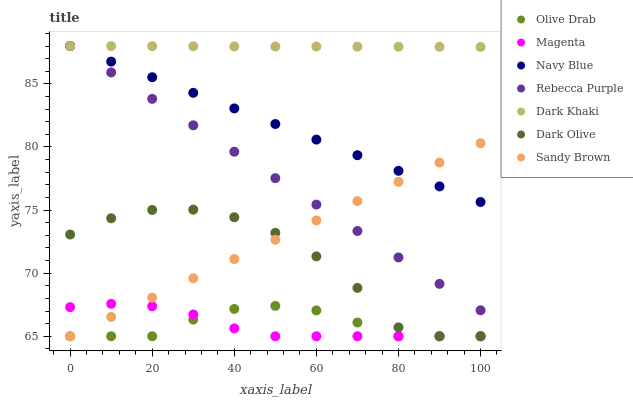Does Magenta have the minimum area under the curve?
Answer yes or no. Yes. Does Dark Khaki have the maximum area under the curve?
Answer yes or no. Yes. Does Dark Olive have the minimum area under the curve?
Answer yes or no. No. Does Dark Olive have the maximum area under the curve?
Answer yes or no. No. Is Navy Blue the smoothest?
Answer yes or no. Yes. Is Dark Olive the roughest?
Answer yes or no. Yes. Is Dark Khaki the smoothest?
Answer yes or no. No. Is Dark Khaki the roughest?
Answer yes or no. No. Does Dark Olive have the lowest value?
Answer yes or no. Yes. Does Dark Khaki have the lowest value?
Answer yes or no. No. Does Rebecca Purple have the highest value?
Answer yes or no. Yes. Does Dark Olive have the highest value?
Answer yes or no. No. Is Olive Drab less than Rebecca Purple?
Answer yes or no. Yes. Is Navy Blue greater than Dark Olive?
Answer yes or no. Yes. Does Navy Blue intersect Dark Khaki?
Answer yes or no. Yes. Is Navy Blue less than Dark Khaki?
Answer yes or no. No. Is Navy Blue greater than Dark Khaki?
Answer yes or no. No. Does Olive Drab intersect Rebecca Purple?
Answer yes or no. No. 